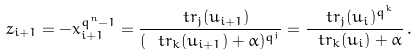Convert formula to latex. <formula><loc_0><loc_0><loc_500><loc_500>z _ { i + 1 } = - x _ { i + 1 } ^ { q ^ { n } - 1 } = \frac { \ t r _ { j } ( u _ { i + 1 } ) } { ( \ t r _ { k } ( u _ { i + 1 } ) + \alpha ) ^ { q ^ { j } } } = \frac { \ t r _ { j } ( u _ { i } ) ^ { q ^ { k } } } { \ t r _ { k } ( u _ { i } ) + \alpha } \, .</formula> 